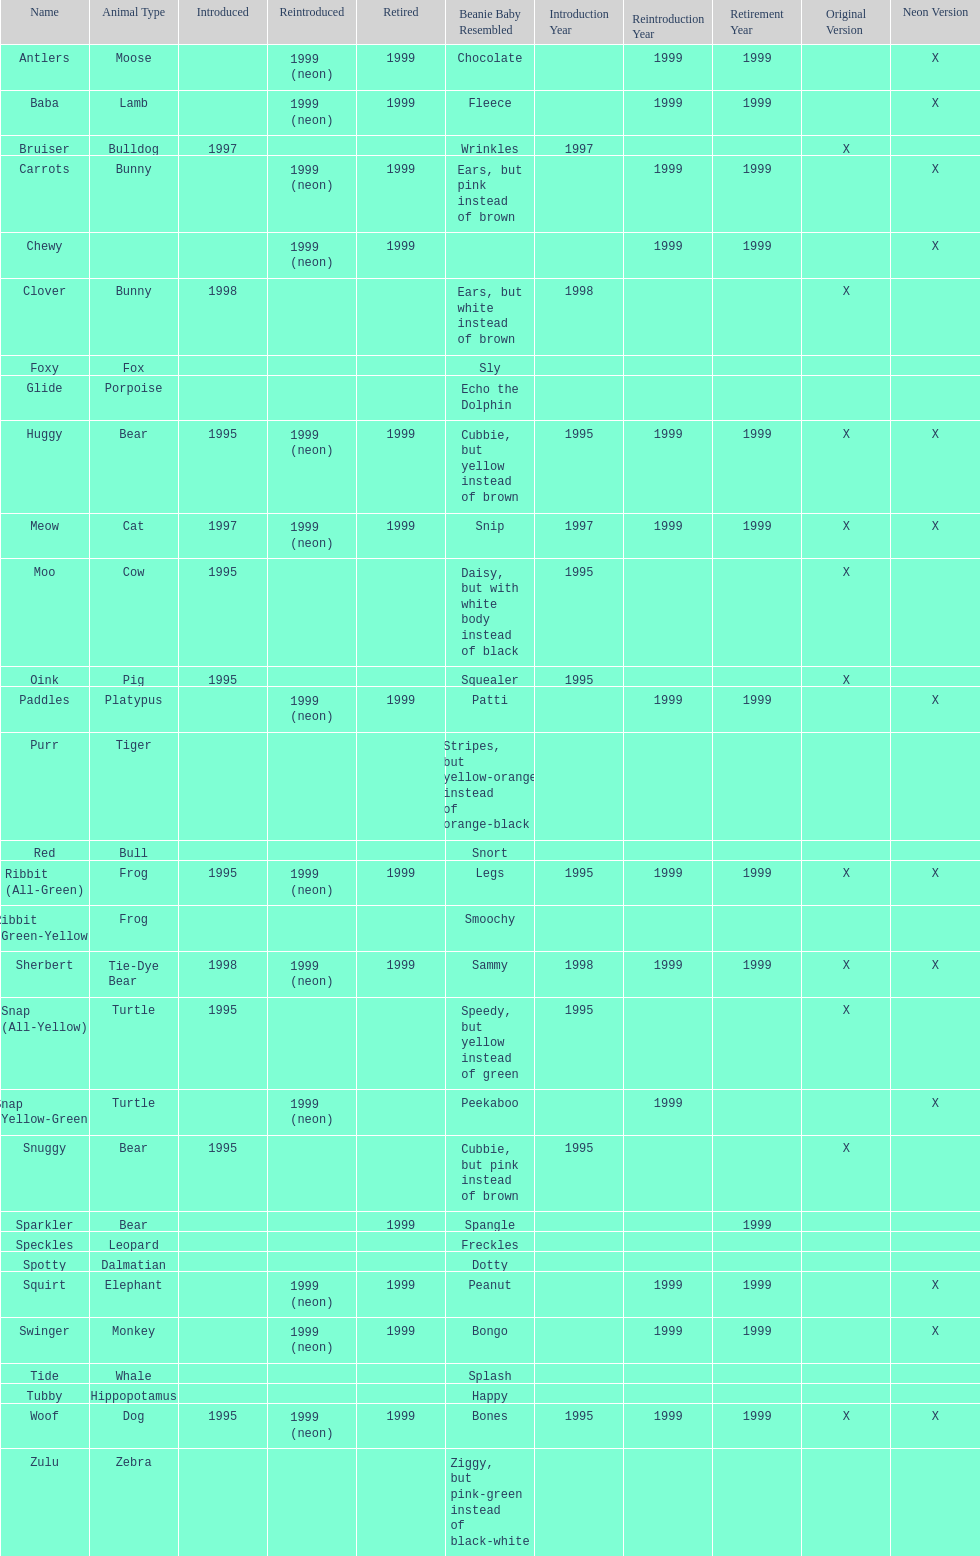What is the name of the pillow pal listed after clover? Foxy. 